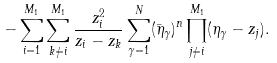<formula> <loc_0><loc_0><loc_500><loc_500>- \sum _ { i = 1 } ^ { M _ { 1 } } \sum _ { k \neq i } ^ { M _ { 1 } } \frac { z _ { i } ^ { 2 } } { z _ { i } - z _ { k } } \sum ^ { N } _ { \gamma = 1 } ( \bar { \eta } _ { \gamma } ) ^ { n } \prod ^ { M _ { 1 } } _ { j \neq i } ( \eta _ { \gamma } - z _ { j } ) .</formula> 